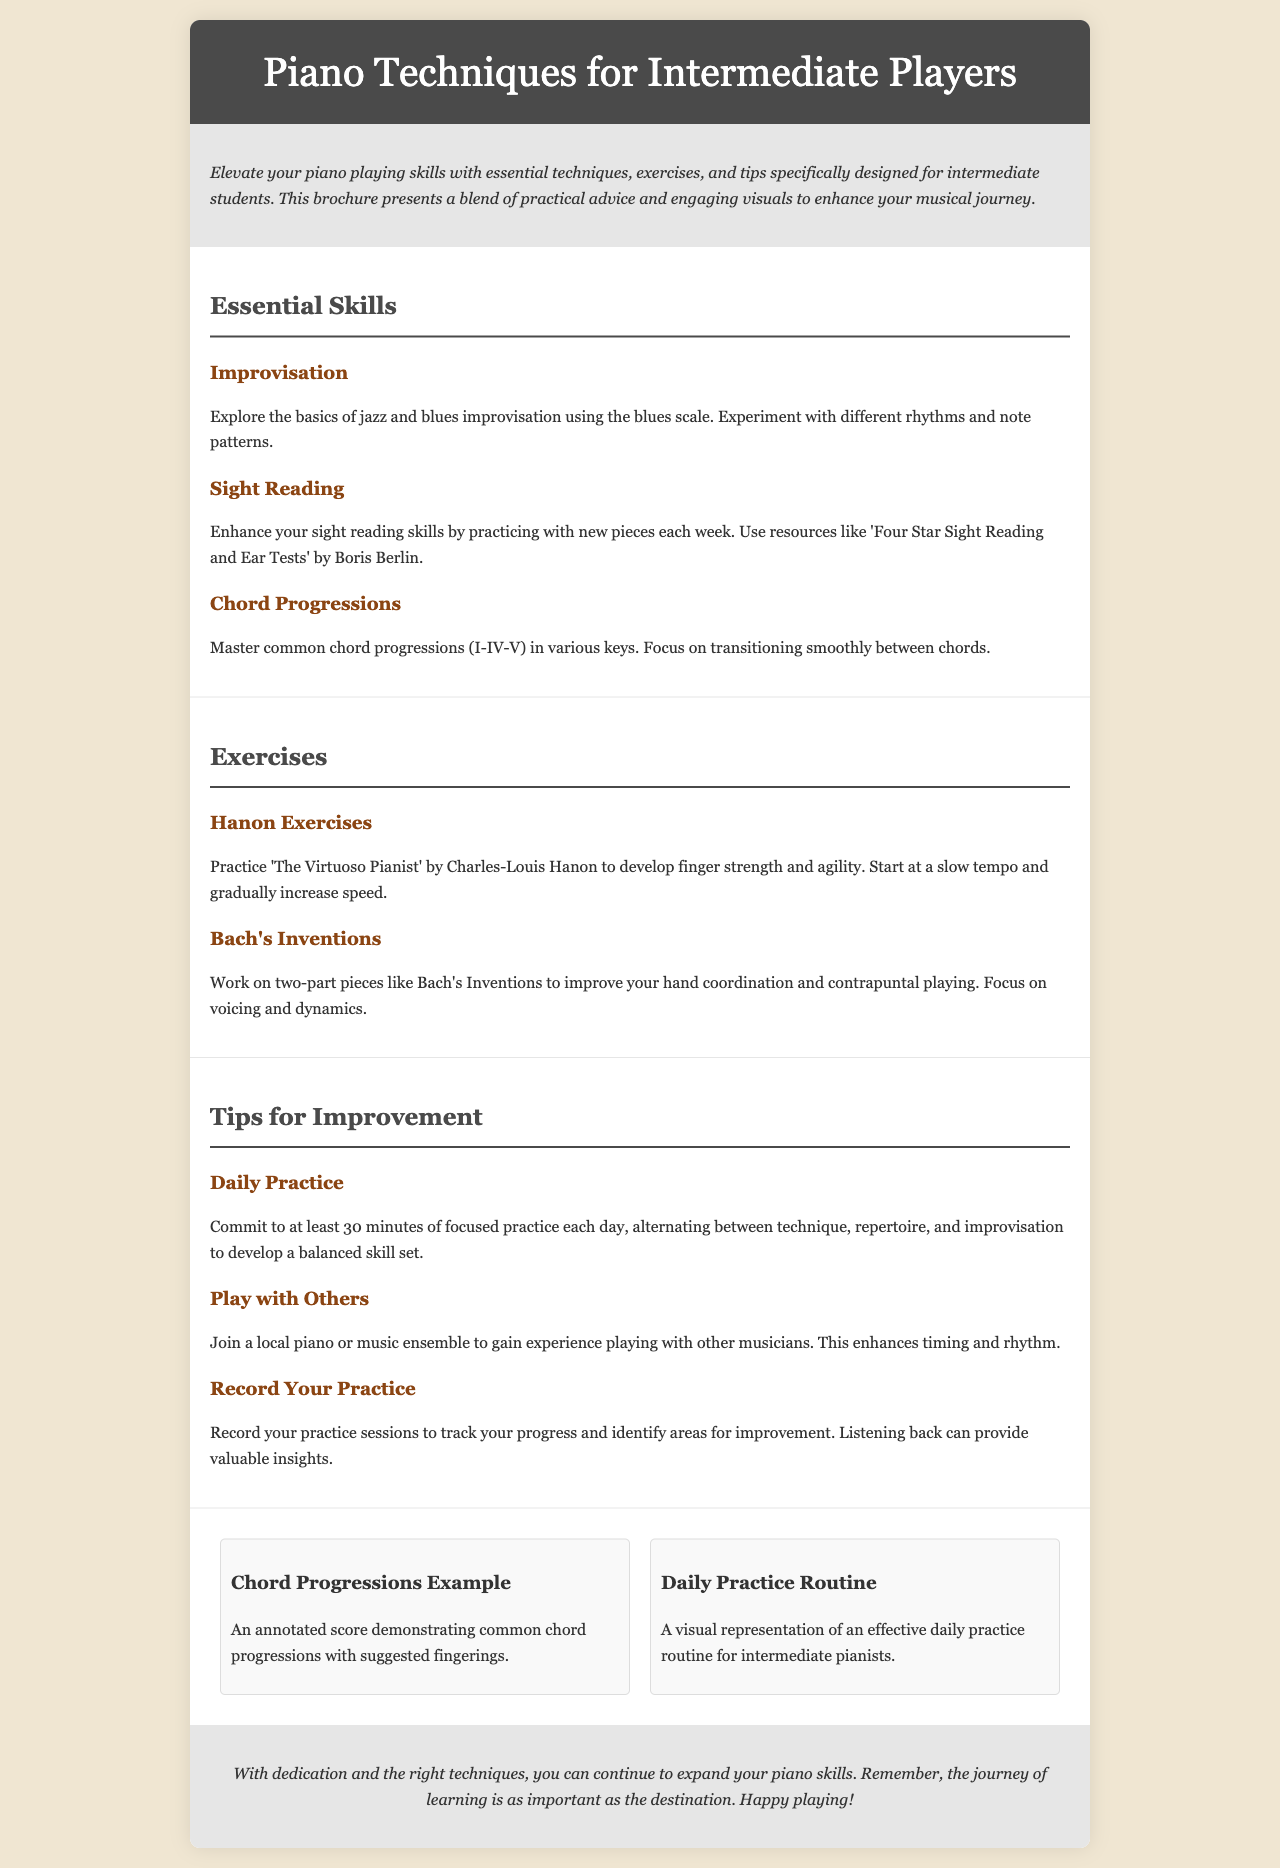what is the title of the brochure? The title of the brochure is stated in the header section.
Answer: Piano Techniques for Intermediate Players how many essential skills are listed? The number of essential skills can be counted in the section titled "Essential Skills."
Answer: 3 what exercise is suggested to develop finger strength? This information is found in the Exercises section where specific exercises are mentioned.
Answer: Hanon Exercises who is the author of "The Virtuoso Pianist"? The author is mentioned in the description of the Hanon Exercises.
Answer: Charles-Louis Hanon what is the recommended daily practice time? This information is provided in the Tips for Improvement section.
Answer: 30 minutes what type of ensemble is recommended for improving skills? The type of activity for social practice is indicated in the Tips for Improvement section.
Answer: music ensemble which skill focuses on jazz and blues? This skill is described in the Essential Skills section, specifically focusing on improvisation.
Answer: Improvisation how many visuals are included? The number of visual items can be counted in the visuals section.
Answer: 2 what is the color of the header background? The document describes the appearance of the header in the style section.
Answer: #4a4a4a 